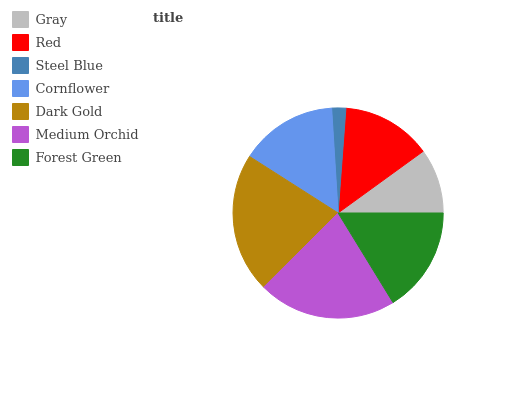Is Steel Blue the minimum?
Answer yes or no. Yes. Is Dark Gold the maximum?
Answer yes or no. Yes. Is Red the minimum?
Answer yes or no. No. Is Red the maximum?
Answer yes or no. No. Is Red greater than Gray?
Answer yes or no. Yes. Is Gray less than Red?
Answer yes or no. Yes. Is Gray greater than Red?
Answer yes or no. No. Is Red less than Gray?
Answer yes or no. No. Is Cornflower the high median?
Answer yes or no. Yes. Is Cornflower the low median?
Answer yes or no. Yes. Is Medium Orchid the high median?
Answer yes or no. No. Is Forest Green the low median?
Answer yes or no. No. 